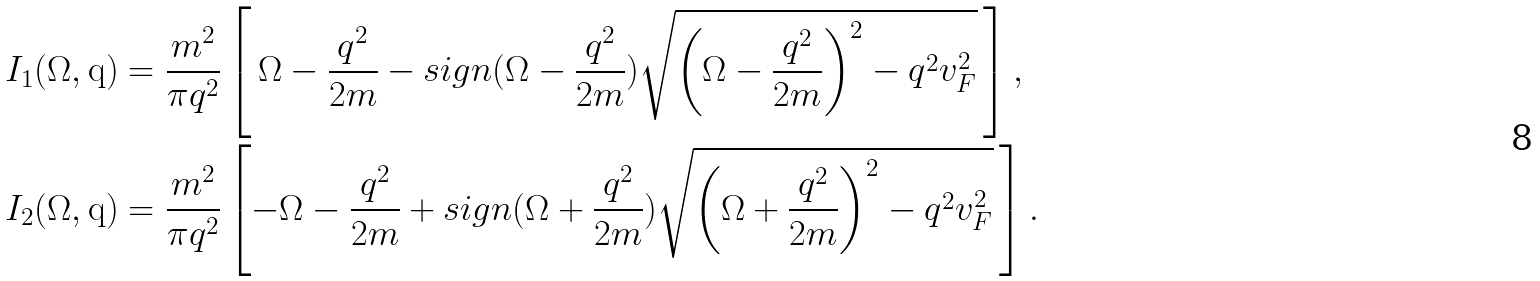<formula> <loc_0><loc_0><loc_500><loc_500>I _ { 1 } ( \Omega , \mathrm q ) & = \frac { m ^ { 2 } } { \pi q ^ { 2 } } \left [ \, \Omega - \frac { q ^ { 2 } } { 2 m } - s i g n ( \Omega - \frac { q ^ { 2 } } { 2 m } ) \sqrt { \left ( \Omega - \frac { q ^ { 2 } } { 2 m } \right ) ^ { 2 } - q ^ { 2 } v _ { F } ^ { 2 } } \, \right ] , \\ I _ { 2 } ( \Omega , \mathrm q ) & = \frac { m ^ { 2 } } { \pi q ^ { 2 } } \left [ - \Omega - \frac { q ^ { 2 } } { 2 m } + s i g n ( \Omega + \frac { q ^ { 2 } } { 2 m } ) \sqrt { \left ( \Omega + \frac { q ^ { 2 } } { 2 m } \right ) ^ { 2 } - q ^ { 2 } v _ { F } ^ { 2 } } \, \right ] .</formula> 